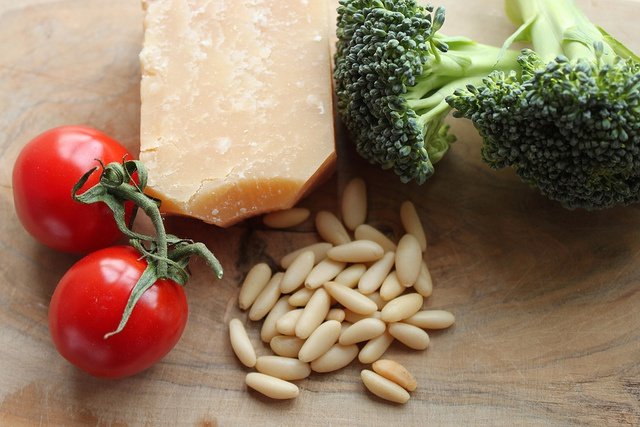Describe the objects in this image and their specific colors. I can see broccoli in lightgray, black, lightyellow, and darkgreen tones and broccoli in lightgray, black, darkgreen, gray, and olive tones in this image. 